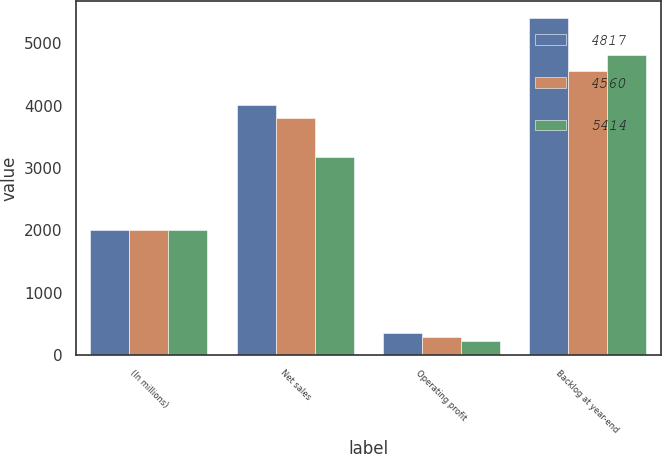Convert chart to OTSL. <chart><loc_0><loc_0><loc_500><loc_500><stacked_bar_chart><ecel><fcel>(In millions)<fcel>Net sales<fcel>Operating profit<fcel>Backlog at year-end<nl><fcel>4817<fcel>2005<fcel>4010<fcel>351<fcel>5414<nl><fcel>4560<fcel>2004<fcel>3802<fcel>285<fcel>4560<nl><fcel>5414<fcel>2003<fcel>3176<fcel>226<fcel>4817<nl></chart> 